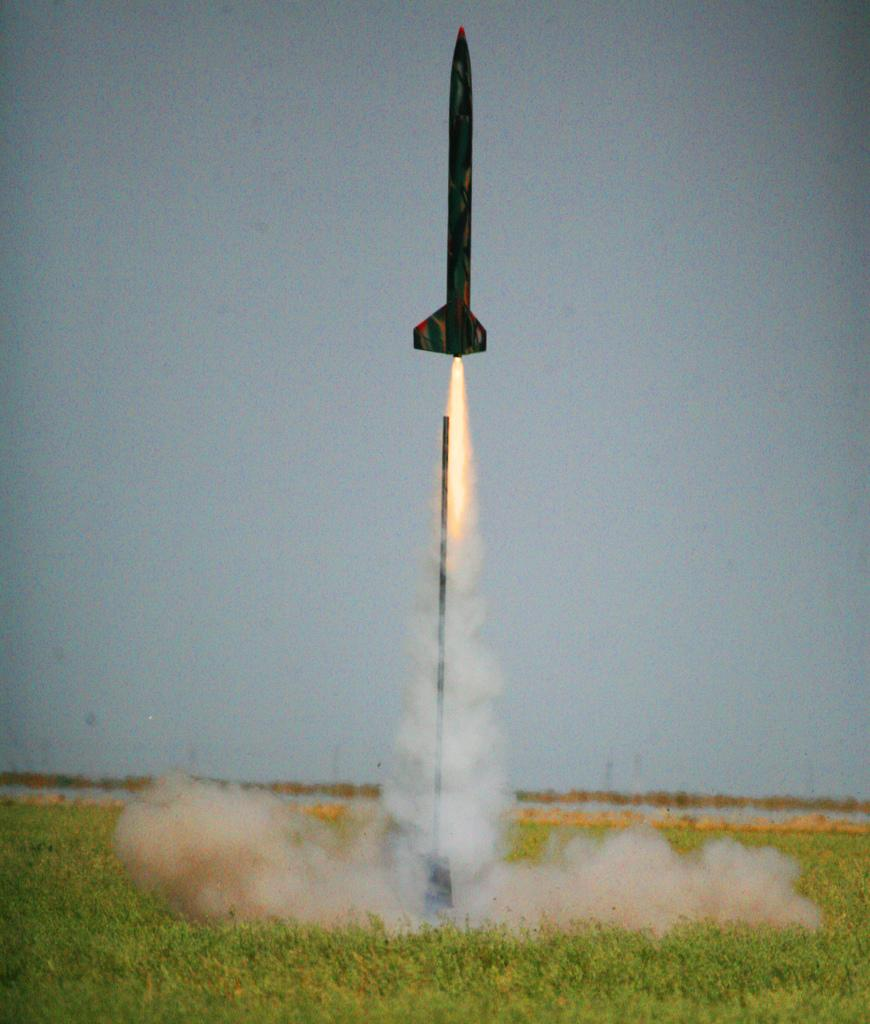What is the main subject of the image? The main subject of the image is a rocket. What is the rocket doing in the image? The rocket is blasting off into the sky. What type of art is being represented by the rocket in the image? The image does not depict a specific type of art; it simply shows a rocket blasting off into the sky. What type of machine is the rocket in the image? The rocket in the image is a vehicle designed for space travel, but it is not a specific type of machine. 